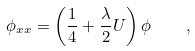<formula> <loc_0><loc_0><loc_500><loc_500>\phi _ { x x } = \left ( \frac { 1 } { 4 } + \frac { \lambda } { 2 } U \right ) \phi \quad ,</formula> 